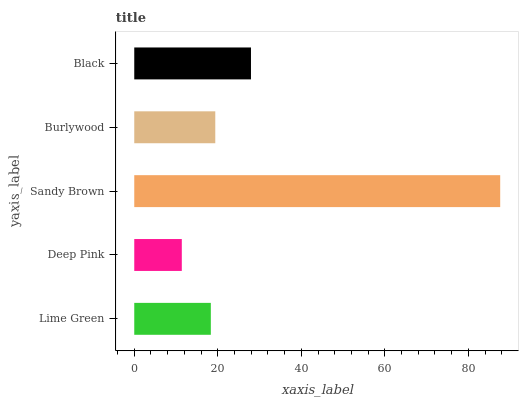Is Deep Pink the minimum?
Answer yes or no. Yes. Is Sandy Brown the maximum?
Answer yes or no. Yes. Is Sandy Brown the minimum?
Answer yes or no. No. Is Deep Pink the maximum?
Answer yes or no. No. Is Sandy Brown greater than Deep Pink?
Answer yes or no. Yes. Is Deep Pink less than Sandy Brown?
Answer yes or no. Yes. Is Deep Pink greater than Sandy Brown?
Answer yes or no. No. Is Sandy Brown less than Deep Pink?
Answer yes or no. No. Is Burlywood the high median?
Answer yes or no. Yes. Is Burlywood the low median?
Answer yes or no. Yes. Is Sandy Brown the high median?
Answer yes or no. No. Is Sandy Brown the low median?
Answer yes or no. No. 